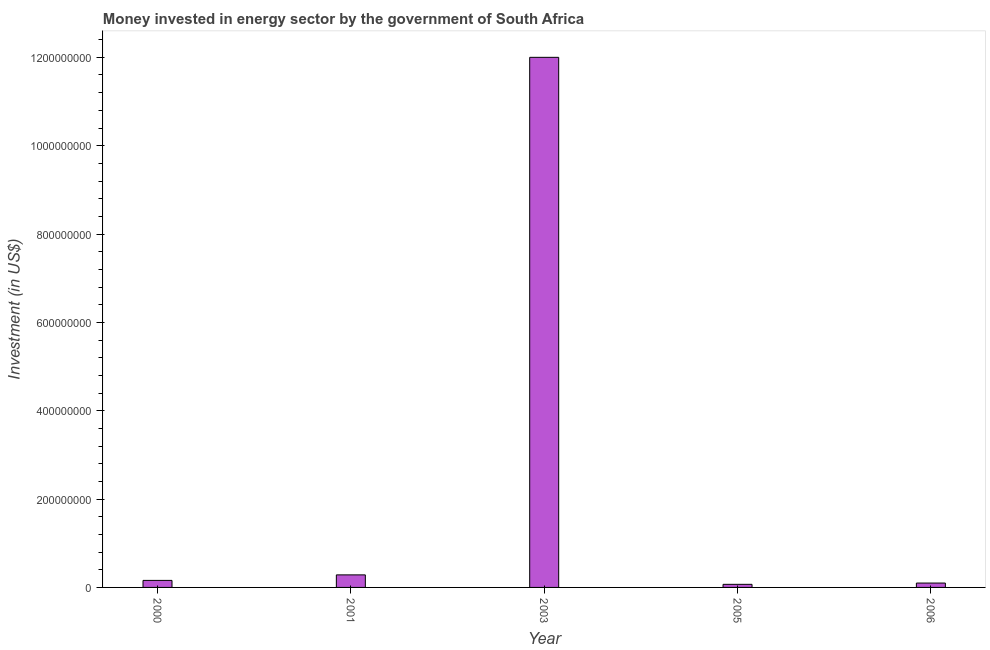Does the graph contain any zero values?
Your answer should be compact. No. Does the graph contain grids?
Your response must be concise. No. What is the title of the graph?
Offer a very short reply. Money invested in energy sector by the government of South Africa. What is the label or title of the Y-axis?
Make the answer very short. Investment (in US$). What is the investment in energy in 2005?
Offer a very short reply. 7.00e+06. Across all years, what is the maximum investment in energy?
Provide a succinct answer. 1.20e+09. In which year was the investment in energy maximum?
Keep it short and to the point. 2003. What is the sum of the investment in energy?
Provide a succinct answer. 1.26e+09. What is the difference between the investment in energy in 2000 and 2005?
Provide a succinct answer. 8.90e+06. What is the average investment in energy per year?
Your response must be concise. 2.52e+08. What is the median investment in energy?
Your response must be concise. 1.59e+07. In how many years, is the investment in energy greater than 480000000 US$?
Make the answer very short. 1. What is the ratio of the investment in energy in 2000 to that in 2006?
Offer a terse response. 1.61. What is the difference between the highest and the second highest investment in energy?
Ensure brevity in your answer.  1.17e+09. What is the difference between the highest and the lowest investment in energy?
Make the answer very short. 1.19e+09. In how many years, is the investment in energy greater than the average investment in energy taken over all years?
Offer a very short reply. 1. Are all the bars in the graph horizontal?
Your answer should be compact. No. What is the difference between two consecutive major ticks on the Y-axis?
Offer a very short reply. 2.00e+08. Are the values on the major ticks of Y-axis written in scientific E-notation?
Ensure brevity in your answer.  No. What is the Investment (in US$) of 2000?
Your answer should be compact. 1.59e+07. What is the Investment (in US$) in 2001?
Ensure brevity in your answer.  2.84e+07. What is the Investment (in US$) of 2003?
Make the answer very short. 1.20e+09. What is the Investment (in US$) of 2006?
Provide a succinct answer. 9.90e+06. What is the difference between the Investment (in US$) in 2000 and 2001?
Your response must be concise. -1.25e+07. What is the difference between the Investment (in US$) in 2000 and 2003?
Your answer should be very brief. -1.18e+09. What is the difference between the Investment (in US$) in 2000 and 2005?
Your answer should be compact. 8.90e+06. What is the difference between the Investment (in US$) in 2000 and 2006?
Provide a succinct answer. 6.00e+06. What is the difference between the Investment (in US$) in 2001 and 2003?
Your answer should be very brief. -1.17e+09. What is the difference between the Investment (in US$) in 2001 and 2005?
Your answer should be very brief. 2.14e+07. What is the difference between the Investment (in US$) in 2001 and 2006?
Ensure brevity in your answer.  1.85e+07. What is the difference between the Investment (in US$) in 2003 and 2005?
Your answer should be compact. 1.19e+09. What is the difference between the Investment (in US$) in 2003 and 2006?
Provide a short and direct response. 1.19e+09. What is the difference between the Investment (in US$) in 2005 and 2006?
Offer a terse response. -2.90e+06. What is the ratio of the Investment (in US$) in 2000 to that in 2001?
Provide a short and direct response. 0.56. What is the ratio of the Investment (in US$) in 2000 to that in 2003?
Keep it short and to the point. 0.01. What is the ratio of the Investment (in US$) in 2000 to that in 2005?
Ensure brevity in your answer.  2.27. What is the ratio of the Investment (in US$) in 2000 to that in 2006?
Your answer should be very brief. 1.61. What is the ratio of the Investment (in US$) in 2001 to that in 2003?
Provide a succinct answer. 0.02. What is the ratio of the Investment (in US$) in 2001 to that in 2005?
Your answer should be very brief. 4.06. What is the ratio of the Investment (in US$) in 2001 to that in 2006?
Offer a terse response. 2.87. What is the ratio of the Investment (in US$) in 2003 to that in 2005?
Offer a very short reply. 171.43. What is the ratio of the Investment (in US$) in 2003 to that in 2006?
Keep it short and to the point. 121.21. What is the ratio of the Investment (in US$) in 2005 to that in 2006?
Keep it short and to the point. 0.71. 